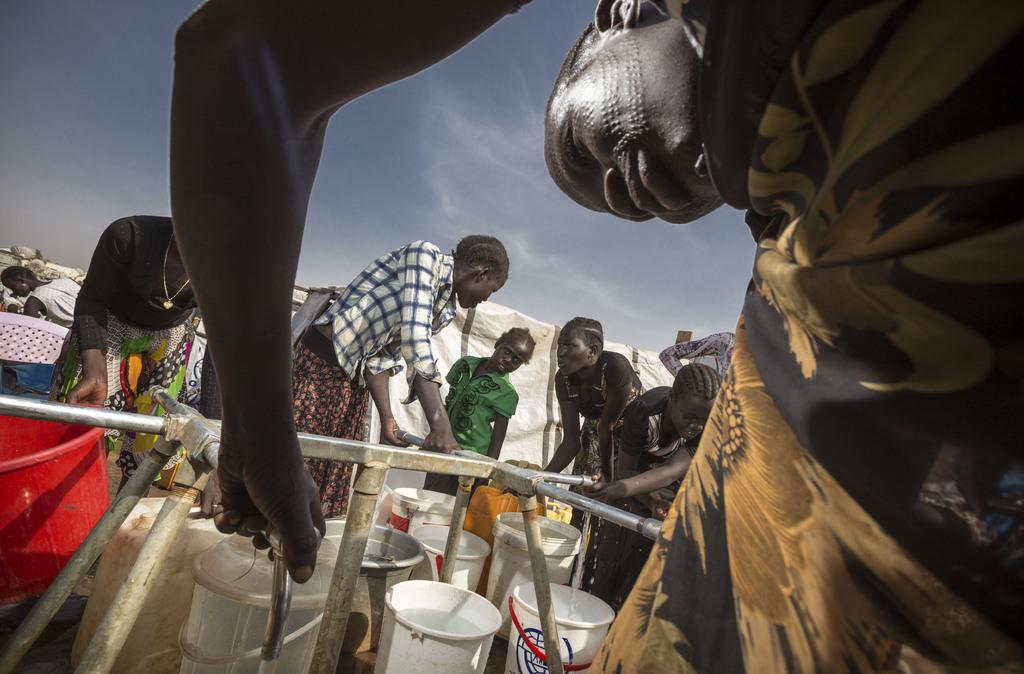How many people are in the image? There is a group of people in the image. What objects can be seen in the image that are used for holding water? There are buckets and taps in the image. What type of plumbing feature is present in the image? There are pipes in the image. What else can be seen in the image besides the people and water-related objects? There are some unspecified objects in the image. What is visible in the background of the image? The sky is visible in the background of the image. What type of bell can be heard ringing in the image? There is no bell present in the image, and therefore no sound can be heard. 